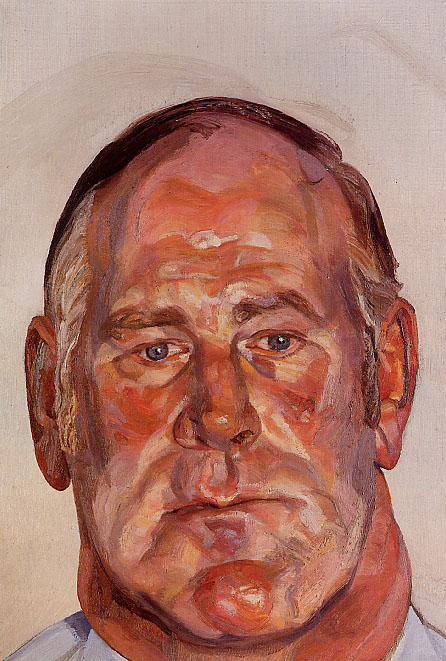What is this photo about? This image is an expressionist portrait of a man, skillfully executed in oil on canvas. The painting captures the man with his eyes closed, giving an impression of deep introspection or serene contemplation. The artist employs a palette dominated by warm orange, red, and pink tones, creating a vivid contrast with the subdued beige background. This choice of colors, along with the thick, textured brushwork, is quintessential of expressionist art which seeks to convey personal emotions and human experiences rather than realistic details. The raw, emotional impact of the painting is characterized by the expressive use of paint and the poignant human expression, making it a compelling study of human emotion as captured through the abstract qualities typical of the expressionist style. 